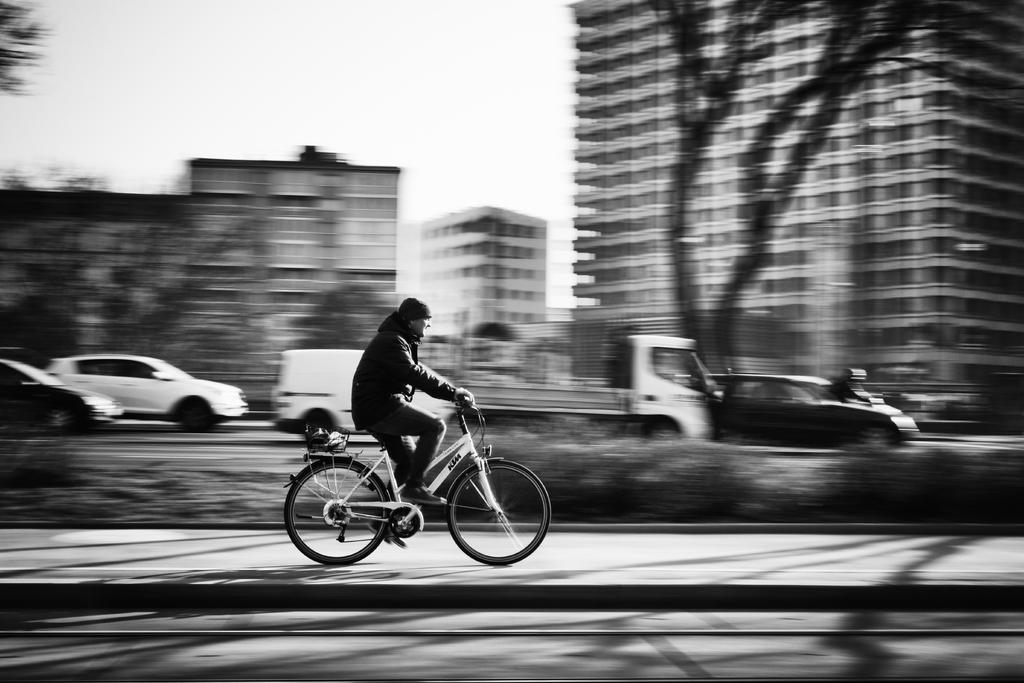What is the man in the image doing? The man is riding a bicycle in the image. Where is the man riding the bicycle? The man is on the road. What else can be seen on the road in the image? There are vehicles traveling on the road. What can be seen in the background of the image? There are buildings visible in the image. What type of voice can be heard coming from the man riding the bicycle in the image? There is no indication of any voice or sound in the image, as it is a still photograph. 